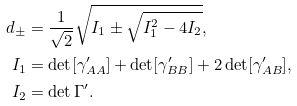<formula> <loc_0><loc_0><loc_500><loc_500>d _ { \pm } & = \frac { 1 } { \sqrt { 2 } } \sqrt { I _ { 1 } \pm \sqrt { I _ { 1 } ^ { 2 } - 4 I _ { 2 } } } , \\ I _ { 1 } & = \det [ \gamma ^ { \prime } _ { A A } ] + \det [ \gamma ^ { \prime } _ { B B } ] + 2 \det [ \gamma ^ { \prime } _ { A B } ] , \\ I _ { 2 } & = \det { \Gamma ^ { \prime } } .</formula> 